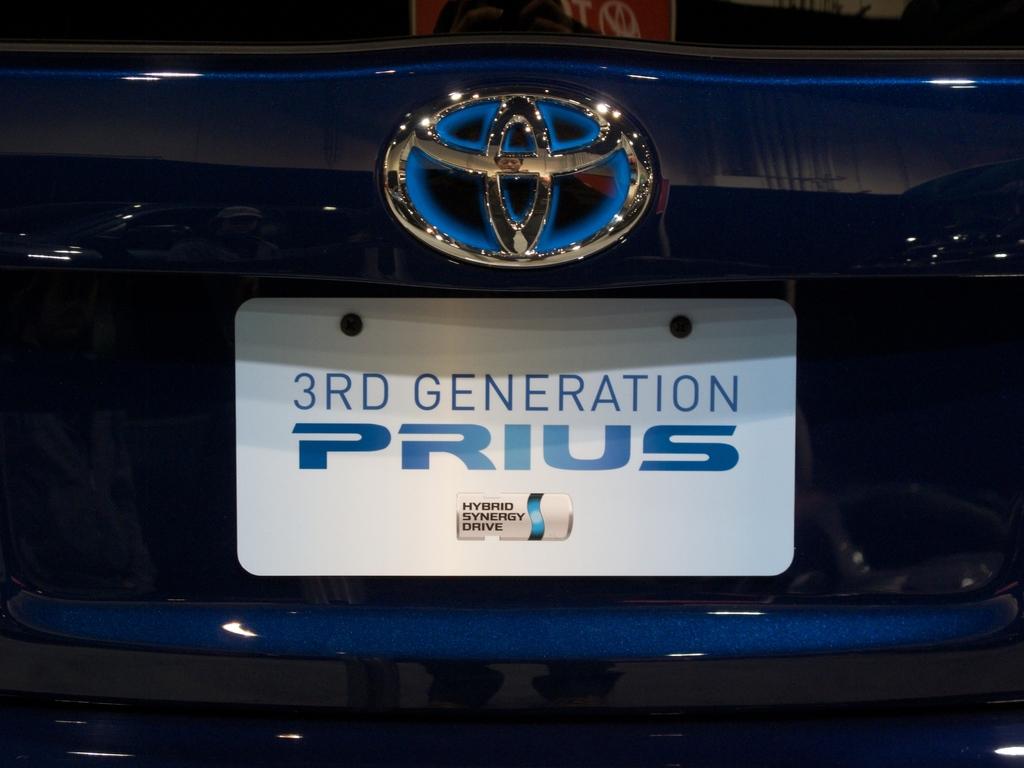What brand of car is this?
Give a very brief answer. Prius. What kind of synergy drive is this?
Make the answer very short. Hybrid. 